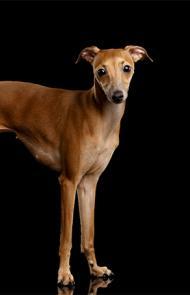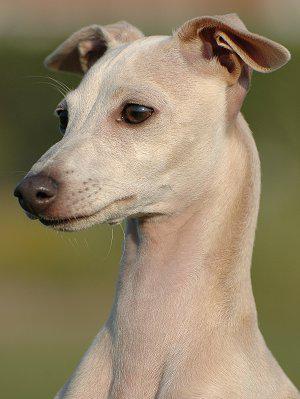The first image is the image on the left, the second image is the image on the right. Given the left and right images, does the statement "Left image shows a hound standing on a hard surface." hold true? Answer yes or no. Yes. 